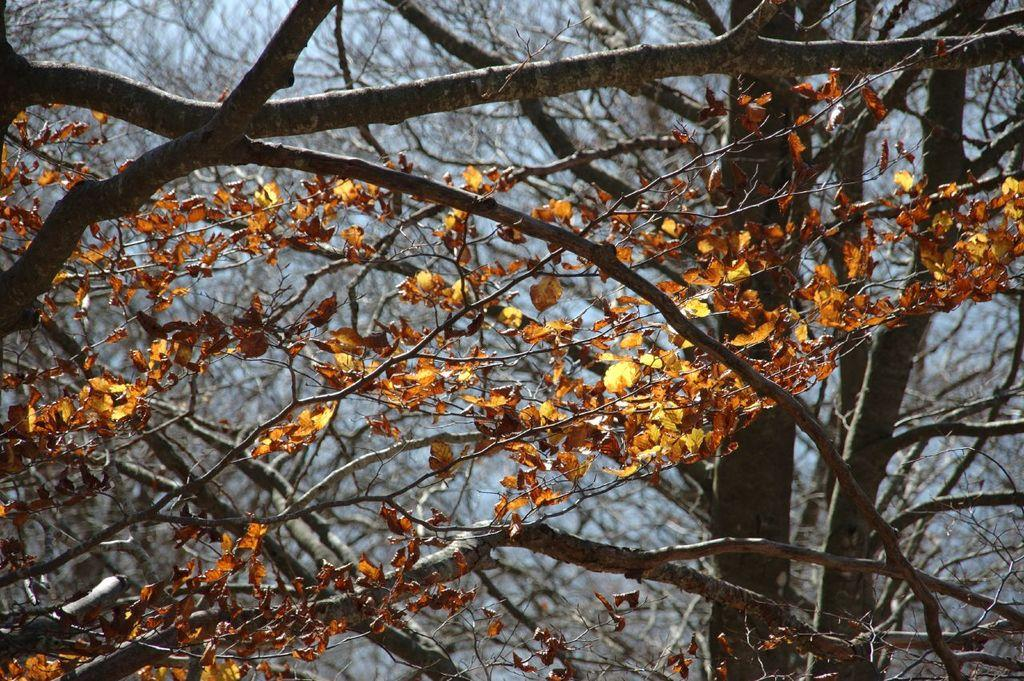What type of vegetation can be seen in the image? There are branches of a tree with leaves in the image. What part of the natural environment is visible in the image? The sky is visible in the image. What type of shock can be seen in the image? There is no shock present in the image; it features branches of a tree with leaves and the sky. Where is the drawer located in the image? There is no drawer present in the image. 